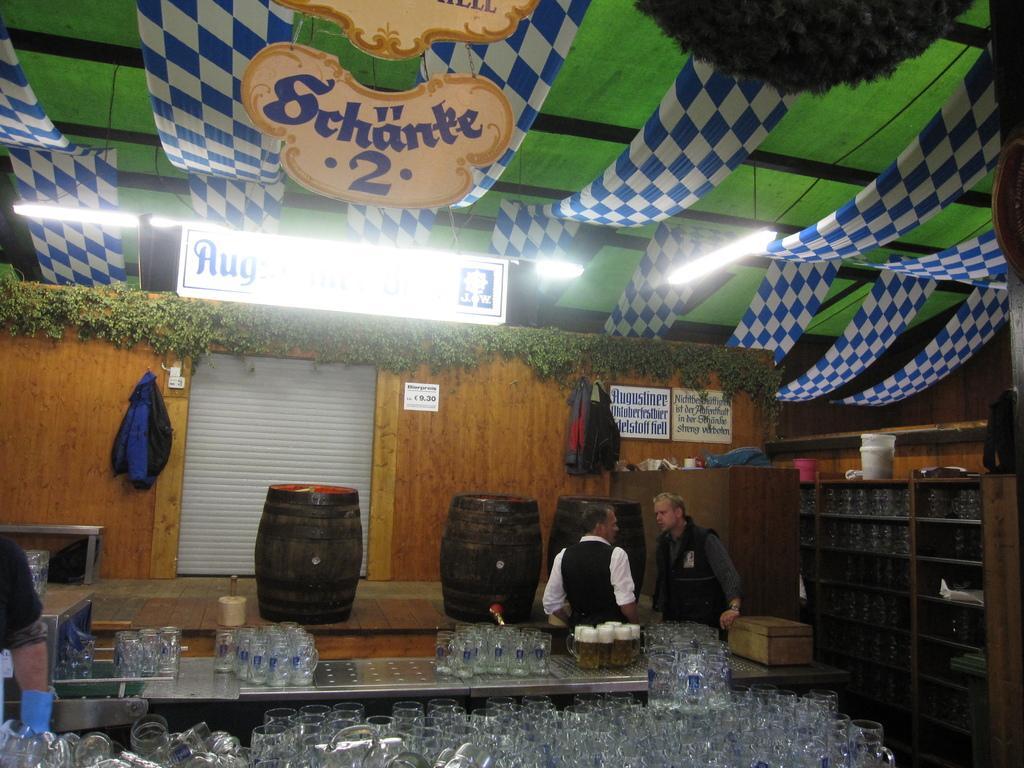In one or two sentences, can you explain what this image depicts? In this image, we can see so many glasses, table, wooden barrels, wooden shelves, few objects, things. Here we can see few people, wooden wall, boards, stickers, hoarding, lights, plants, decorative items, banners. 